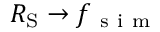<formula> <loc_0><loc_0><loc_500><loc_500>R _ { S } \rightarrow f _ { s i m }</formula> 